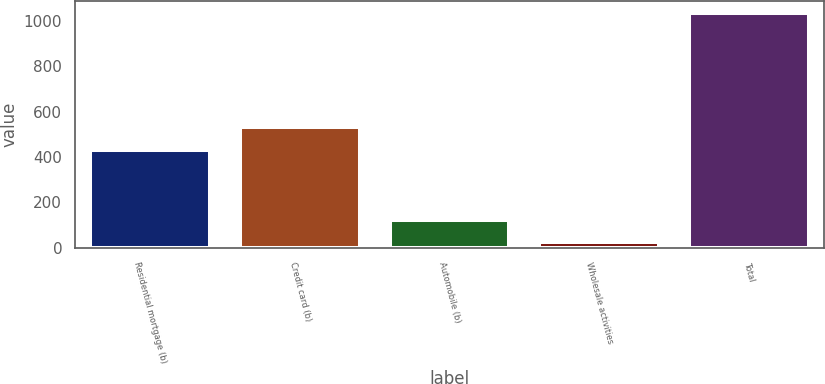<chart> <loc_0><loc_0><loc_500><loc_500><bar_chart><fcel>Residential mortgage (b)<fcel>Credit card (b)<fcel>Automobile (b)<fcel>Wholesale activities<fcel>Total<nl><fcel>433<fcel>534.2<fcel>124.2<fcel>23<fcel>1035<nl></chart> 